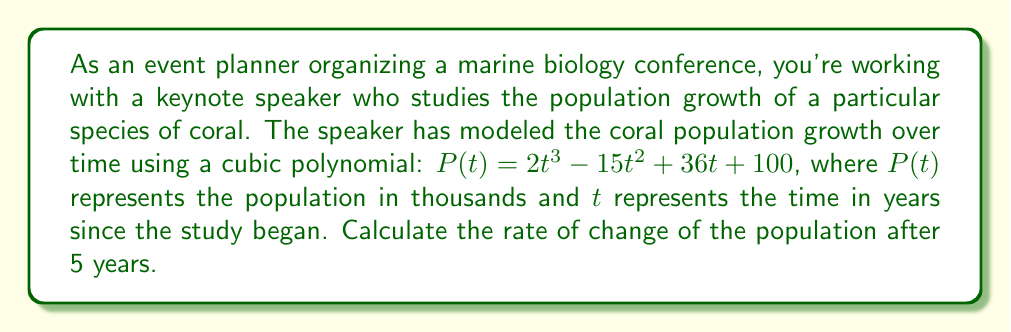Could you help me with this problem? To find the rate of change of the population after 5 years, we need to follow these steps:

1) The rate of change of a function at any point is given by its derivative at that point.

2) First, let's find the derivative of the population function $P(t)$:

   $P(t) = 2t^3 - 15t^2 + 36t + 100$
   $P'(t) = 6t^2 - 30t + 36$

   This is obtained by applying the power rule of differentiation:
   - The derivative of $2t^3$ is $3 \cdot 2t^2 = 6t^2$
   - The derivative of $-15t^2$ is $2 \cdot (-15t) = -30t$
   - The derivative of $36t$ is $36$
   - The constant term 100 becomes 0 when differentiated

3) Now that we have the derivative, we need to evaluate it at $t = 5$ years:

   $P'(5) = 6(5)^2 - 30(5) + 36$
   
4) Let's calculate this step by step:
   
   $P'(5) = 6(25) - 30(5) + 36$
   $P'(5) = 150 - 150 + 36$
   $P'(5) = 36$

5) Therefore, after 5 years, the rate of change of the population is 36 thousand per year.
Answer: 36 thousand per year 